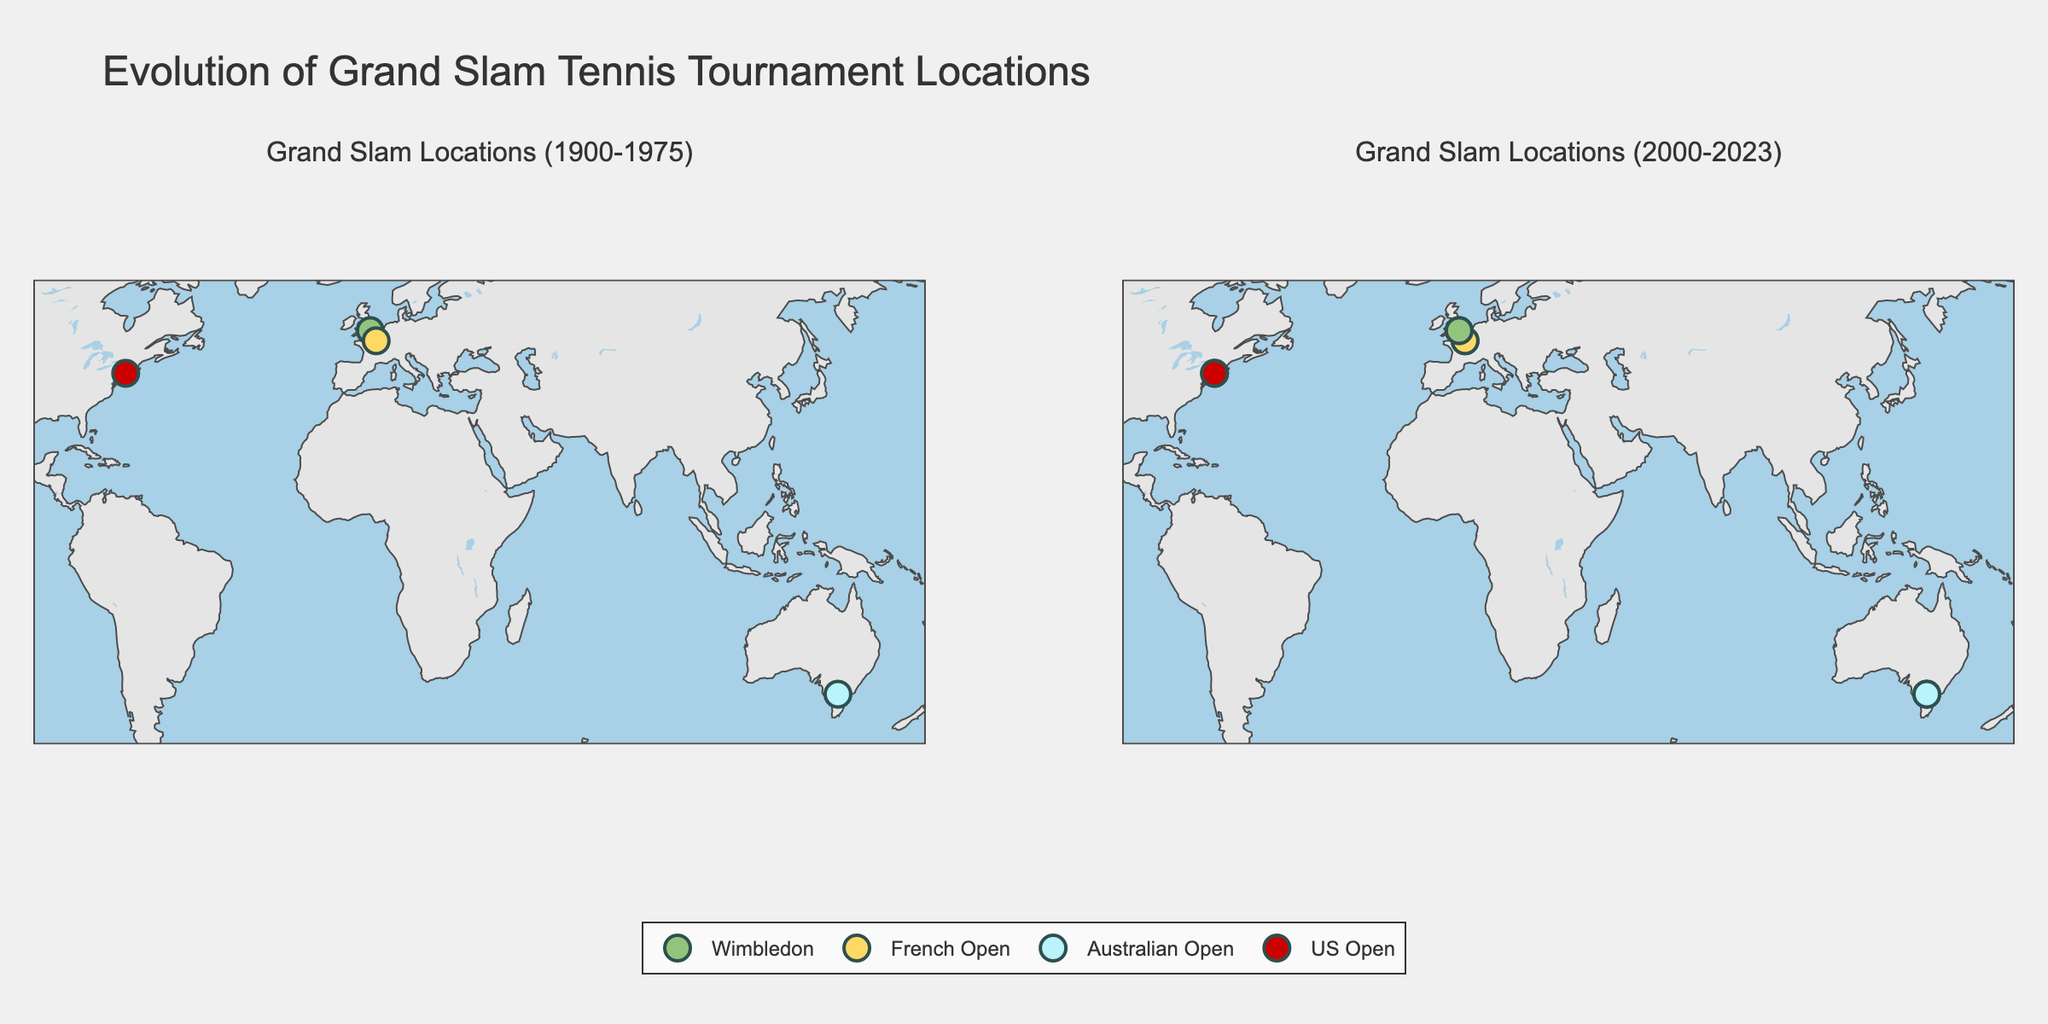What are the four Grand Slam tournaments shown in the plot? The plot includes four Grand Slam tournaments: Australian Open, French Open, Wimbledon, and US Open. This can be observed from the legend which lists these tournaments and colors associated with each.
Answer: Australian Open, French Open, Wimbledon, US Open Which years are compared in the two subplots? The subplot titles specify the years compared: the left subplot shows data from 1900-1975, and the right subplot shows data from 2000-2023.
Answer: 1900-1975 and 2000-2023 How many unique cities hosted Grand Slam tournaments from 1900 to 1975? There are three unique cities (London, Paris, New York City) that hosted Grand Slam tournaments in the specified period, which can be identified by observing the dot locations on the left subplot.
Answer: 3 Which city appears in both subplots for the French Open? Both subplots have markers for Paris, which indicates that Paris is the city for the French Open in both periods.
Answer: Paris How do the geographical locations of the tournaments change from 1900-1975 to 2000-2023? The locations remain consistent except for the addition of Melbourne in the newer subplot (2000-2023). Initially, the plot shows three cities: London, Paris, and New York City. Later, Melbourne is added to the map.
Answer: Melbourne is added Which tournament is represented by the highest number of markers across both subplots? By counting the number of markers, the US Open appears most frequently across both subplots, with two markers in each period (once in 1975 and three times in 2000, three times in 2023).
Answer: US Open Which Grand Slam tournament is the only one located in the Southern Hemisphere? The only Southern Hemisphere tournament visible in the plot is the Australian Open, as indicated by the southernmost marker in Melbourne, Australia.
Answer: Australian Open What colors are used for the Wimbledon tournament in the plot? The legend shows Wimbledon is represented by the color green in both subplots. This can also be confirmed by the green dots located in London.
Answer: Green Between the years 1900-1975, how many different countries hosted a Grand Slam tournament? By identifying the unique countries, we see United Kingdom, France, and United States host tournaments, hence three different countries.
Answer: 3 Compare the frequency of the US Open tournament between 1900-1975 and 2000-2023. There is one marker for the US Open in the first subplot (1975) but four markers in the second subplot (2000, 2023). This shows an increase in the number of times the tournament is represented.
Answer: More frequent in 2000-2023 